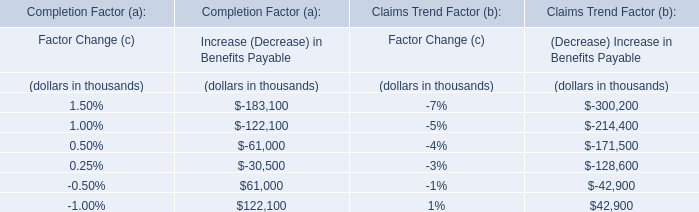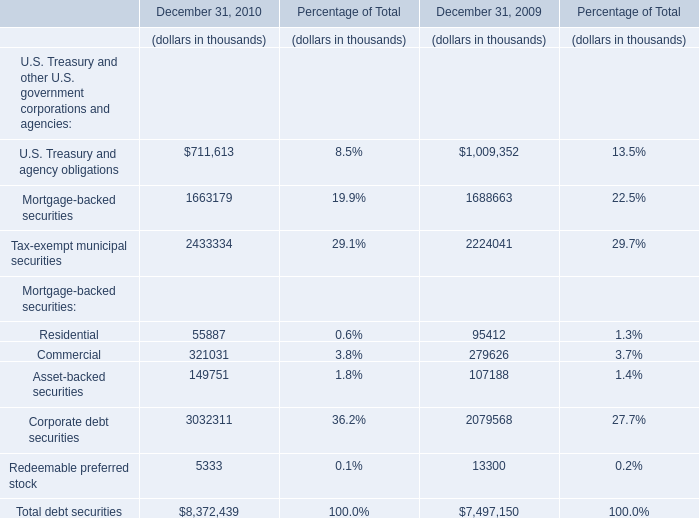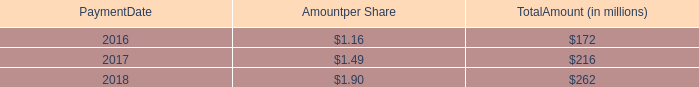At December 31, what year is the value of Asset-backed securities higher? 
Answer: 2010. 